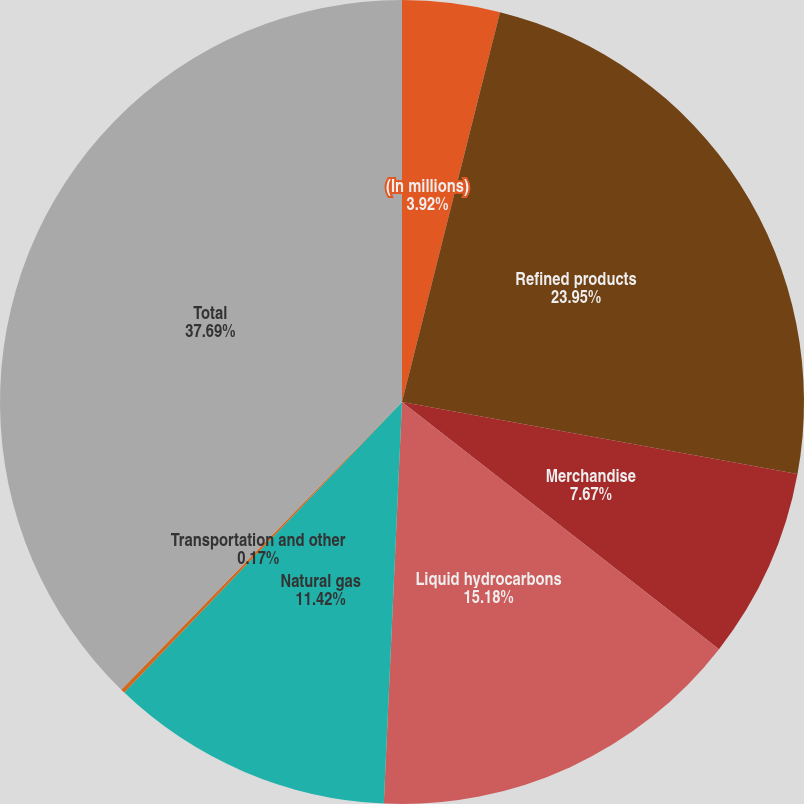<chart> <loc_0><loc_0><loc_500><loc_500><pie_chart><fcel>(In millions)<fcel>Refined products<fcel>Merchandise<fcel>Liquid hydrocarbons<fcel>Natural gas<fcel>Transportation and other<fcel>Total<nl><fcel>3.92%<fcel>23.95%<fcel>7.67%<fcel>15.18%<fcel>11.42%<fcel>0.17%<fcel>37.69%<nl></chart> 